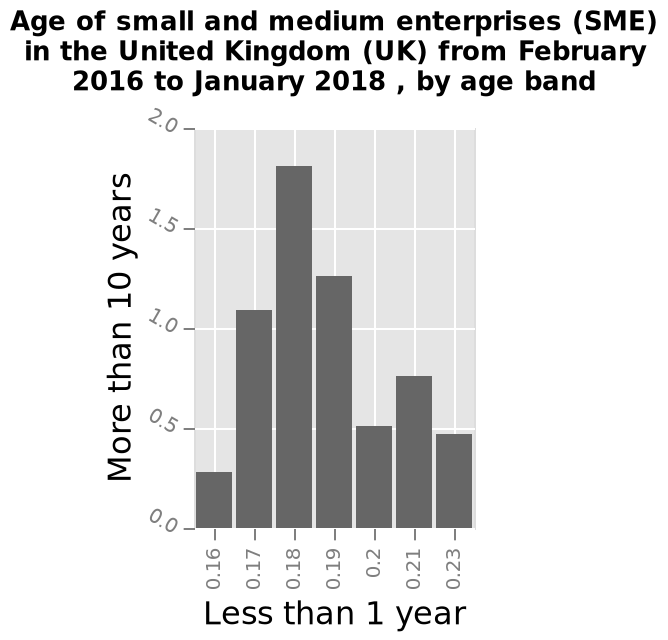<image>
What does the x-axis in the bar graph represent? The x-axis represents the age band of small and medium enterprises, specifically "Less than 1 year." please summary the statistics and relations of the chart Most small and medium enterprises in the UK from February 2016 to January 2018 fall in the 0.18/1.8 band. It seems that most enterprises are 1.8 years old or 0.18 years old.(I don't think I am able to interpret this graph correctly, I really don't understand how to read this even though I researched online about this stat). Did the person researching online about this stat understand how to read the graph? No, the person mentioned that they don't think they are able to interpret the graph correctly despite researching online about this stat. What is the time period specified in the figure?  The time period specified in the figure is from February 2016 to January 2018. 